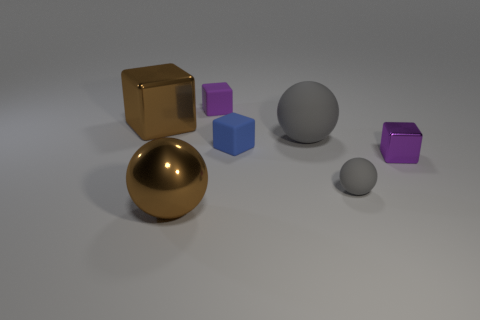What number of red things are small shiny things or large metal spheres? In the image, there are no red objects that fit the description of being either small shiny things or large metal spheres. Therefore, the answer is zero. 